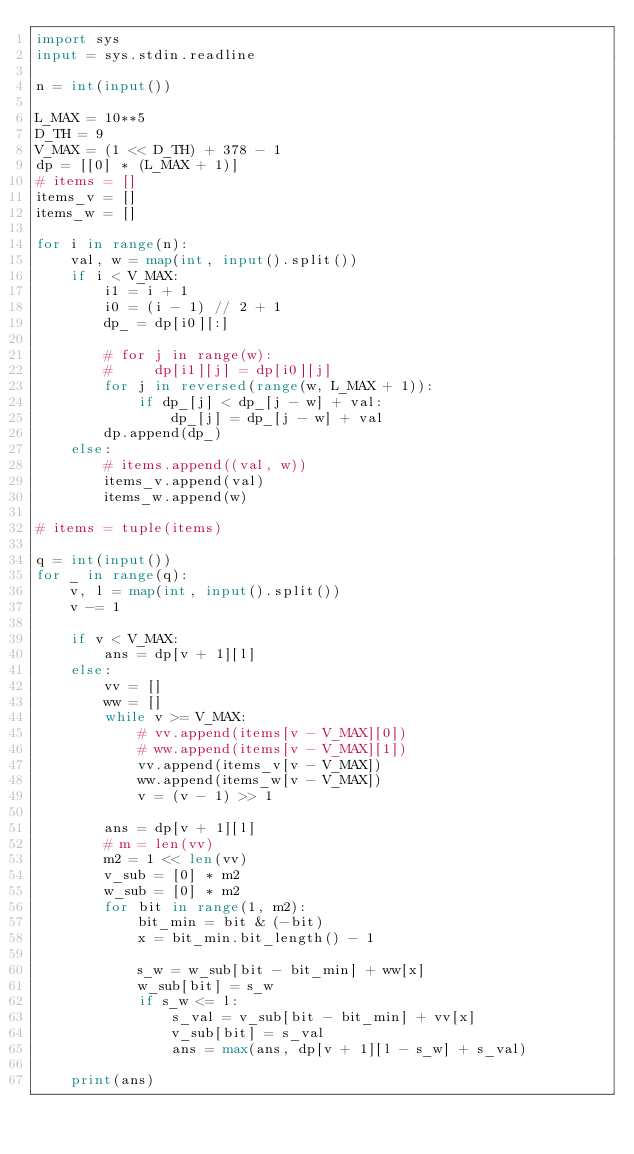Convert code to text. <code><loc_0><loc_0><loc_500><loc_500><_Python_>import sys
input = sys.stdin.readline

n = int(input())

L_MAX = 10**5
D_TH = 9
V_MAX = (1 << D_TH) + 378 - 1
dp = [[0] * (L_MAX + 1)]
# items = []
items_v = []
items_w = []

for i in range(n):
    val, w = map(int, input().split())
    if i < V_MAX:
        i1 = i + 1
        i0 = (i - 1) // 2 + 1
        dp_ = dp[i0][:]

        # for j in range(w):
        #     dp[i1][j] = dp[i0][j]
        for j in reversed(range(w, L_MAX + 1)):
            if dp_[j] < dp_[j - w] + val:
                dp_[j] = dp_[j - w] + val
        dp.append(dp_)
    else:
        # items.append((val, w))
        items_v.append(val)
        items_w.append(w)

# items = tuple(items)

q = int(input())
for _ in range(q):
    v, l = map(int, input().split())
    v -= 1

    if v < V_MAX:
        ans = dp[v + 1][l]
    else:
        vv = []
        ww = []
        while v >= V_MAX:
            # vv.append(items[v - V_MAX][0])
            # ww.append(items[v - V_MAX][1])
            vv.append(items_v[v - V_MAX])
            ww.append(items_w[v - V_MAX])
            v = (v - 1) >> 1

        ans = dp[v + 1][l]
        # m = len(vv)
        m2 = 1 << len(vv)
        v_sub = [0] * m2
        w_sub = [0] * m2
        for bit in range(1, m2):
            bit_min = bit & (-bit)
            x = bit_min.bit_length() - 1

            s_w = w_sub[bit - bit_min] + ww[x]
            w_sub[bit] = s_w
            if s_w <= l:
                s_val = v_sub[bit - bit_min] + vv[x]
                v_sub[bit] = s_val
                ans = max(ans, dp[v + 1][l - s_w] + s_val)

    print(ans)
</code> 